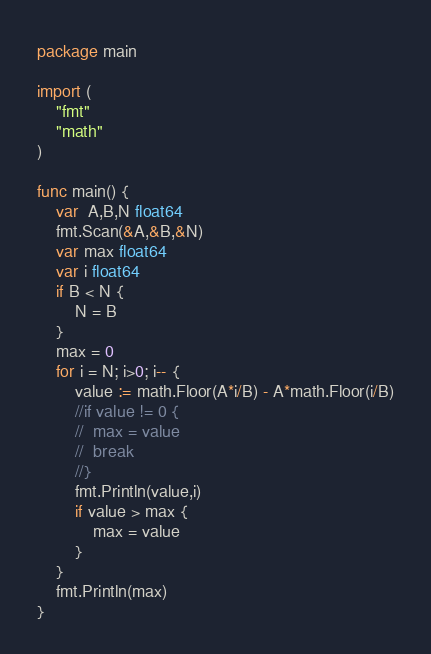<code> <loc_0><loc_0><loc_500><loc_500><_Go_>package main

import (
	"fmt"
	"math"
)

func main() {
	var  A,B,N float64
	fmt.Scan(&A,&B,&N)
	var max float64
	var i float64
	if B < N {
		N = B
	}
	max = 0
	for i = N; i>0; i-- {
		value := math.Floor(A*i/B) - A*math.Floor(i/B)
		//if value != 0 {
		//	max = value
		//	break
		//}
		fmt.Println(value,i)
		if value > max {
			max = value
		}
	}
	fmt.Println(max)
}</code> 